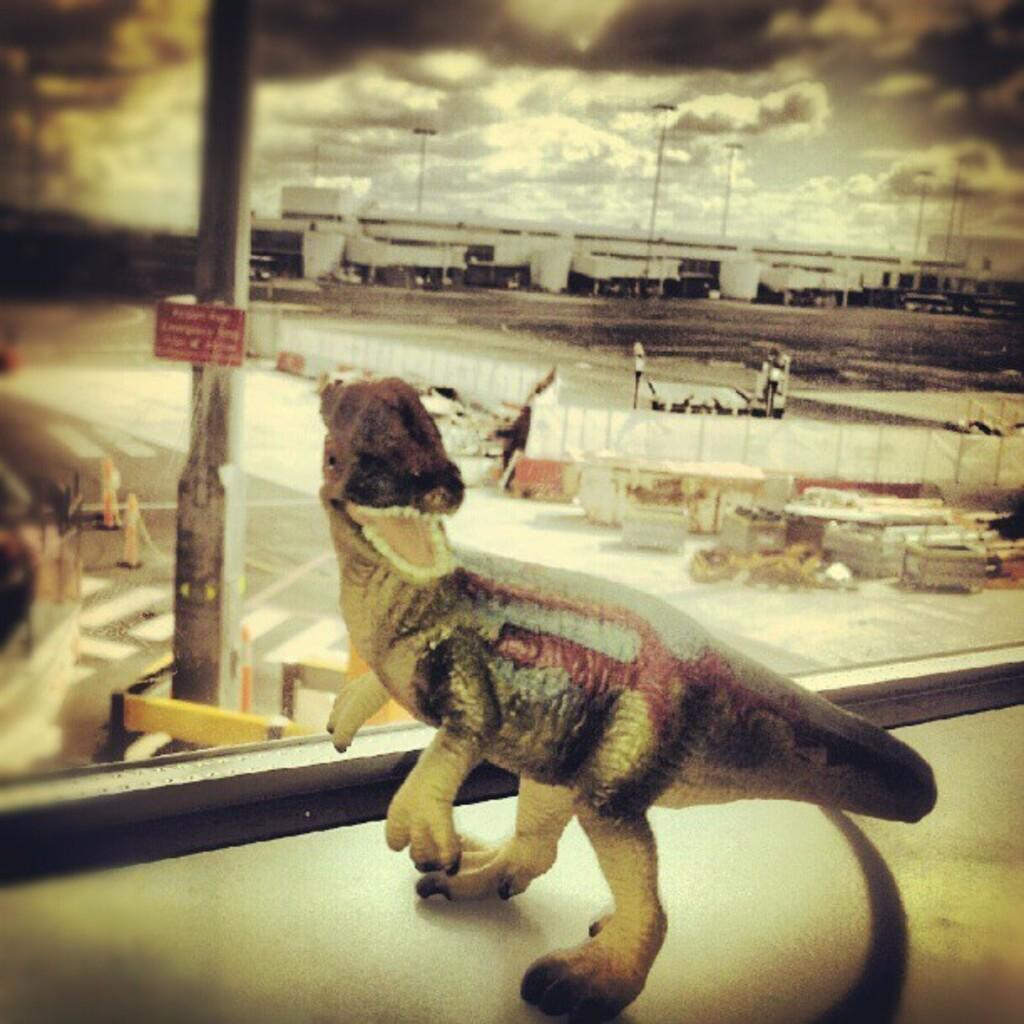What is the main subject in the center of the image? There is a toy dinosaur in the center of the image. What can be seen through the window in the image? There is a window in the center of the image, and buildings, poles, and posters are visible outside the window. How many ploughs can be seen outside the window in the image? There are no ploughs visible outside the window in the image. What type of flight is depicted in the image? There is no flight depicted in the image; it features a toy dinosaur and a window with views of buildings, poles, and posters. 